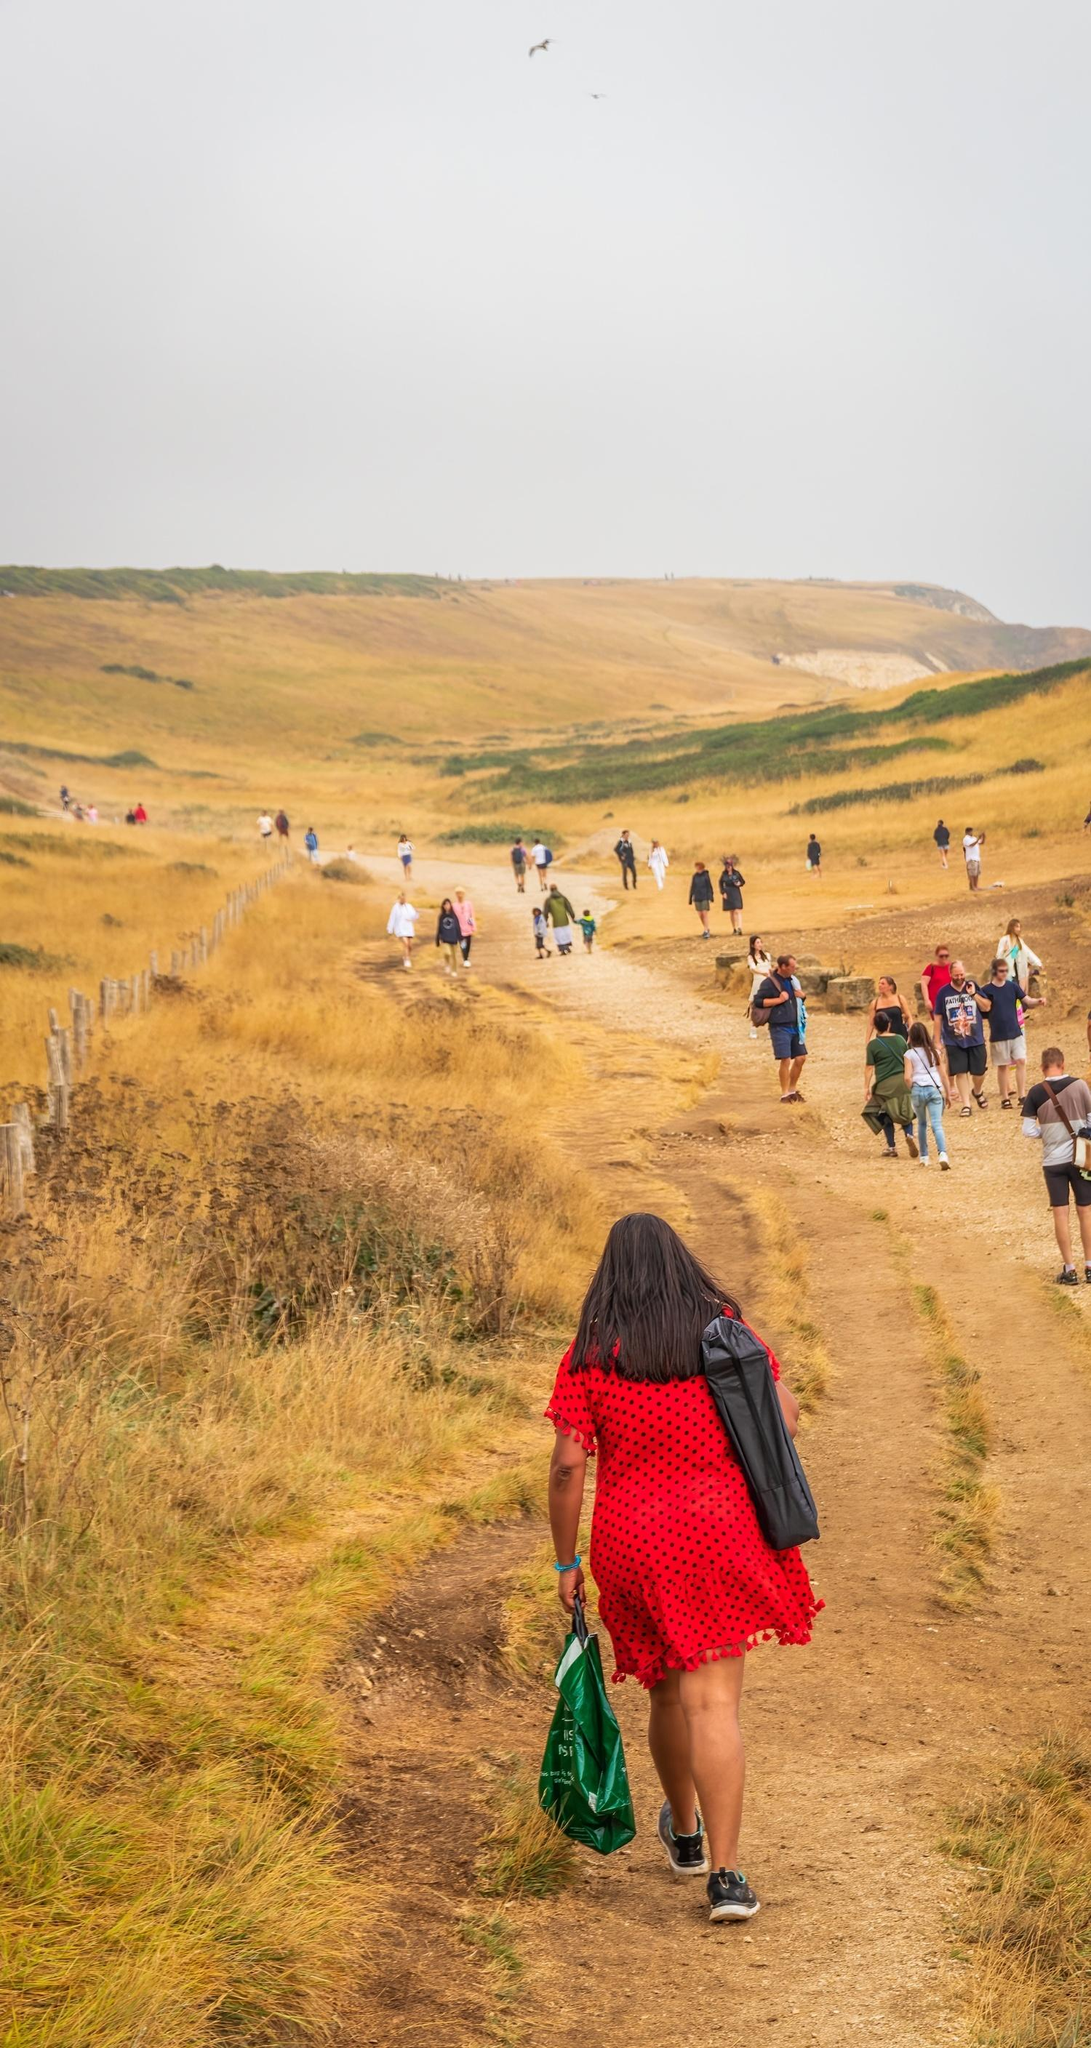If you could imagine this scene transformed into a painting, what style or artistic movements would it represent? If this scene were transformed into a painting, it could represent the Romanticism movement. The picturesque countryside, serene ambience, and focus on nature’s beauty and human connection are elements often found in Romantic art. Alternatively, it might adopt an Impressionist style, with soft brushstrokes capturing the light, colors, and fleeting moments of the scene, evoking a sense of spontaneity and intimacy. 